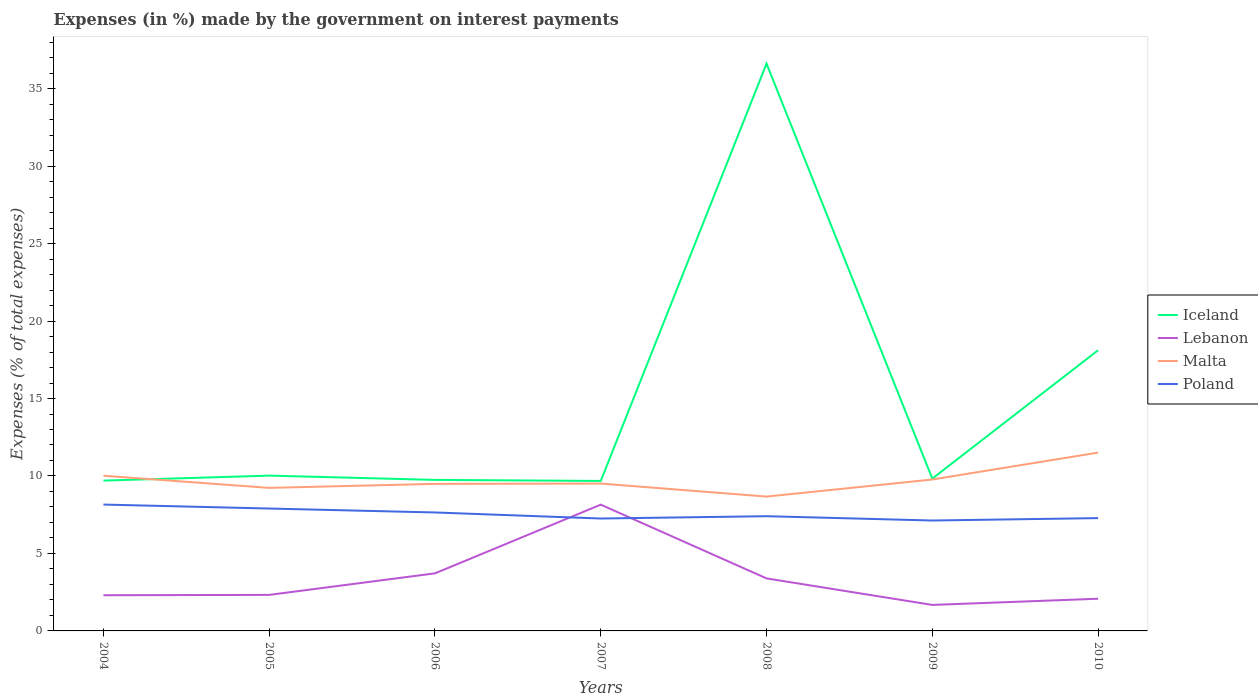Does the line corresponding to Iceland intersect with the line corresponding to Poland?
Make the answer very short. No. Is the number of lines equal to the number of legend labels?
Your answer should be compact. Yes. Across all years, what is the maximum percentage of expenses made by the government on interest payments in Poland?
Provide a succinct answer. 7.13. In which year was the percentage of expenses made by the government on interest payments in Lebanon maximum?
Your answer should be very brief. 2009. What is the total percentage of expenses made by the government on interest payments in Poland in the graph?
Give a very brief answer. 0.77. What is the difference between the highest and the second highest percentage of expenses made by the government on interest payments in Iceland?
Provide a short and direct response. 26.93. Is the percentage of expenses made by the government on interest payments in Iceland strictly greater than the percentage of expenses made by the government on interest payments in Lebanon over the years?
Keep it short and to the point. No. How many lines are there?
Ensure brevity in your answer.  4. How many years are there in the graph?
Your response must be concise. 7. What is the difference between two consecutive major ticks on the Y-axis?
Provide a succinct answer. 5. Does the graph contain any zero values?
Provide a succinct answer. No. How many legend labels are there?
Give a very brief answer. 4. How are the legend labels stacked?
Provide a short and direct response. Vertical. What is the title of the graph?
Provide a short and direct response. Expenses (in %) made by the government on interest payments. What is the label or title of the Y-axis?
Ensure brevity in your answer.  Expenses (% of total expenses). What is the Expenses (% of total expenses) in Iceland in 2004?
Provide a short and direct response. 9.7. What is the Expenses (% of total expenses) in Lebanon in 2004?
Offer a very short reply. 2.3. What is the Expenses (% of total expenses) in Malta in 2004?
Your answer should be compact. 10.02. What is the Expenses (% of total expenses) of Poland in 2004?
Your answer should be compact. 8.16. What is the Expenses (% of total expenses) of Iceland in 2005?
Your answer should be very brief. 10.02. What is the Expenses (% of total expenses) of Lebanon in 2005?
Your answer should be compact. 2.33. What is the Expenses (% of total expenses) in Malta in 2005?
Make the answer very short. 9.23. What is the Expenses (% of total expenses) of Poland in 2005?
Offer a terse response. 7.9. What is the Expenses (% of total expenses) in Iceland in 2006?
Offer a terse response. 9.75. What is the Expenses (% of total expenses) of Lebanon in 2006?
Your answer should be compact. 3.72. What is the Expenses (% of total expenses) of Malta in 2006?
Your answer should be compact. 9.49. What is the Expenses (% of total expenses) of Poland in 2006?
Offer a very short reply. 7.64. What is the Expenses (% of total expenses) of Iceland in 2007?
Give a very brief answer. 9.68. What is the Expenses (% of total expenses) in Lebanon in 2007?
Offer a very short reply. 8.15. What is the Expenses (% of total expenses) of Malta in 2007?
Give a very brief answer. 9.51. What is the Expenses (% of total expenses) of Poland in 2007?
Your answer should be compact. 7.26. What is the Expenses (% of total expenses) in Iceland in 2008?
Keep it short and to the point. 36.61. What is the Expenses (% of total expenses) in Lebanon in 2008?
Offer a very short reply. 3.39. What is the Expenses (% of total expenses) of Malta in 2008?
Your response must be concise. 8.67. What is the Expenses (% of total expenses) in Poland in 2008?
Give a very brief answer. 7.4. What is the Expenses (% of total expenses) of Iceland in 2009?
Ensure brevity in your answer.  9.83. What is the Expenses (% of total expenses) in Lebanon in 2009?
Ensure brevity in your answer.  1.68. What is the Expenses (% of total expenses) of Malta in 2009?
Ensure brevity in your answer.  9.77. What is the Expenses (% of total expenses) of Poland in 2009?
Your answer should be very brief. 7.13. What is the Expenses (% of total expenses) of Iceland in 2010?
Offer a very short reply. 18.11. What is the Expenses (% of total expenses) of Lebanon in 2010?
Ensure brevity in your answer.  2.08. What is the Expenses (% of total expenses) in Malta in 2010?
Keep it short and to the point. 11.51. What is the Expenses (% of total expenses) of Poland in 2010?
Your answer should be very brief. 7.28. Across all years, what is the maximum Expenses (% of total expenses) in Iceland?
Provide a short and direct response. 36.61. Across all years, what is the maximum Expenses (% of total expenses) of Lebanon?
Make the answer very short. 8.15. Across all years, what is the maximum Expenses (% of total expenses) of Malta?
Your response must be concise. 11.51. Across all years, what is the maximum Expenses (% of total expenses) in Poland?
Provide a succinct answer. 8.16. Across all years, what is the minimum Expenses (% of total expenses) of Iceland?
Provide a short and direct response. 9.68. Across all years, what is the minimum Expenses (% of total expenses) of Lebanon?
Provide a short and direct response. 1.68. Across all years, what is the minimum Expenses (% of total expenses) in Malta?
Keep it short and to the point. 8.67. Across all years, what is the minimum Expenses (% of total expenses) of Poland?
Your response must be concise. 7.13. What is the total Expenses (% of total expenses) of Iceland in the graph?
Provide a succinct answer. 103.71. What is the total Expenses (% of total expenses) in Lebanon in the graph?
Keep it short and to the point. 23.64. What is the total Expenses (% of total expenses) in Malta in the graph?
Provide a succinct answer. 68.2. What is the total Expenses (% of total expenses) in Poland in the graph?
Provide a short and direct response. 52.76. What is the difference between the Expenses (% of total expenses) of Iceland in 2004 and that in 2005?
Offer a terse response. -0.32. What is the difference between the Expenses (% of total expenses) of Lebanon in 2004 and that in 2005?
Ensure brevity in your answer.  -0.02. What is the difference between the Expenses (% of total expenses) of Malta in 2004 and that in 2005?
Keep it short and to the point. 0.78. What is the difference between the Expenses (% of total expenses) in Poland in 2004 and that in 2005?
Ensure brevity in your answer.  0.26. What is the difference between the Expenses (% of total expenses) of Iceland in 2004 and that in 2006?
Keep it short and to the point. -0.05. What is the difference between the Expenses (% of total expenses) in Lebanon in 2004 and that in 2006?
Provide a succinct answer. -1.41. What is the difference between the Expenses (% of total expenses) in Malta in 2004 and that in 2006?
Provide a short and direct response. 0.53. What is the difference between the Expenses (% of total expenses) in Poland in 2004 and that in 2006?
Offer a terse response. 0.51. What is the difference between the Expenses (% of total expenses) in Iceland in 2004 and that in 2007?
Ensure brevity in your answer.  0.02. What is the difference between the Expenses (% of total expenses) in Lebanon in 2004 and that in 2007?
Provide a short and direct response. -5.85. What is the difference between the Expenses (% of total expenses) in Malta in 2004 and that in 2007?
Your response must be concise. 0.51. What is the difference between the Expenses (% of total expenses) of Poland in 2004 and that in 2007?
Give a very brief answer. 0.9. What is the difference between the Expenses (% of total expenses) of Iceland in 2004 and that in 2008?
Give a very brief answer. -26.91. What is the difference between the Expenses (% of total expenses) in Lebanon in 2004 and that in 2008?
Ensure brevity in your answer.  -1.09. What is the difference between the Expenses (% of total expenses) of Malta in 2004 and that in 2008?
Give a very brief answer. 1.35. What is the difference between the Expenses (% of total expenses) in Poland in 2004 and that in 2008?
Keep it short and to the point. 0.75. What is the difference between the Expenses (% of total expenses) in Iceland in 2004 and that in 2009?
Provide a succinct answer. -0.13. What is the difference between the Expenses (% of total expenses) in Lebanon in 2004 and that in 2009?
Give a very brief answer. 0.63. What is the difference between the Expenses (% of total expenses) of Malta in 2004 and that in 2009?
Make the answer very short. 0.24. What is the difference between the Expenses (% of total expenses) in Poland in 2004 and that in 2009?
Keep it short and to the point. 1.03. What is the difference between the Expenses (% of total expenses) of Iceland in 2004 and that in 2010?
Give a very brief answer. -8.41. What is the difference between the Expenses (% of total expenses) in Lebanon in 2004 and that in 2010?
Ensure brevity in your answer.  0.23. What is the difference between the Expenses (% of total expenses) of Malta in 2004 and that in 2010?
Your answer should be very brief. -1.49. What is the difference between the Expenses (% of total expenses) of Poland in 2004 and that in 2010?
Provide a succinct answer. 0.87. What is the difference between the Expenses (% of total expenses) in Iceland in 2005 and that in 2006?
Make the answer very short. 0.28. What is the difference between the Expenses (% of total expenses) of Lebanon in 2005 and that in 2006?
Provide a short and direct response. -1.39. What is the difference between the Expenses (% of total expenses) of Malta in 2005 and that in 2006?
Make the answer very short. -0.26. What is the difference between the Expenses (% of total expenses) of Poland in 2005 and that in 2006?
Your answer should be very brief. 0.25. What is the difference between the Expenses (% of total expenses) in Iceland in 2005 and that in 2007?
Your response must be concise. 0.34. What is the difference between the Expenses (% of total expenses) of Lebanon in 2005 and that in 2007?
Provide a short and direct response. -5.82. What is the difference between the Expenses (% of total expenses) of Malta in 2005 and that in 2007?
Your answer should be compact. -0.28. What is the difference between the Expenses (% of total expenses) of Poland in 2005 and that in 2007?
Offer a very short reply. 0.64. What is the difference between the Expenses (% of total expenses) in Iceland in 2005 and that in 2008?
Offer a very short reply. -26.59. What is the difference between the Expenses (% of total expenses) in Lebanon in 2005 and that in 2008?
Offer a terse response. -1.06. What is the difference between the Expenses (% of total expenses) of Malta in 2005 and that in 2008?
Give a very brief answer. 0.56. What is the difference between the Expenses (% of total expenses) in Poland in 2005 and that in 2008?
Offer a very short reply. 0.49. What is the difference between the Expenses (% of total expenses) of Iceland in 2005 and that in 2009?
Provide a succinct answer. 0.19. What is the difference between the Expenses (% of total expenses) in Lebanon in 2005 and that in 2009?
Offer a very short reply. 0.65. What is the difference between the Expenses (% of total expenses) of Malta in 2005 and that in 2009?
Offer a very short reply. -0.54. What is the difference between the Expenses (% of total expenses) of Poland in 2005 and that in 2009?
Give a very brief answer. 0.77. What is the difference between the Expenses (% of total expenses) in Iceland in 2005 and that in 2010?
Your answer should be very brief. -8.09. What is the difference between the Expenses (% of total expenses) in Lebanon in 2005 and that in 2010?
Your answer should be compact. 0.25. What is the difference between the Expenses (% of total expenses) in Malta in 2005 and that in 2010?
Give a very brief answer. -2.28. What is the difference between the Expenses (% of total expenses) in Poland in 2005 and that in 2010?
Your response must be concise. 0.62. What is the difference between the Expenses (% of total expenses) of Iceland in 2006 and that in 2007?
Your answer should be compact. 0.07. What is the difference between the Expenses (% of total expenses) in Lebanon in 2006 and that in 2007?
Your response must be concise. -4.43. What is the difference between the Expenses (% of total expenses) in Malta in 2006 and that in 2007?
Give a very brief answer. -0.02. What is the difference between the Expenses (% of total expenses) of Poland in 2006 and that in 2007?
Your response must be concise. 0.39. What is the difference between the Expenses (% of total expenses) in Iceland in 2006 and that in 2008?
Keep it short and to the point. -26.86. What is the difference between the Expenses (% of total expenses) in Lebanon in 2006 and that in 2008?
Your answer should be compact. 0.33. What is the difference between the Expenses (% of total expenses) in Malta in 2006 and that in 2008?
Ensure brevity in your answer.  0.82. What is the difference between the Expenses (% of total expenses) in Poland in 2006 and that in 2008?
Your answer should be very brief. 0.24. What is the difference between the Expenses (% of total expenses) of Iceland in 2006 and that in 2009?
Provide a short and direct response. -0.08. What is the difference between the Expenses (% of total expenses) in Lebanon in 2006 and that in 2009?
Your response must be concise. 2.04. What is the difference between the Expenses (% of total expenses) in Malta in 2006 and that in 2009?
Your answer should be compact. -0.28. What is the difference between the Expenses (% of total expenses) in Poland in 2006 and that in 2009?
Your answer should be compact. 0.52. What is the difference between the Expenses (% of total expenses) in Iceland in 2006 and that in 2010?
Provide a succinct answer. -8.37. What is the difference between the Expenses (% of total expenses) of Lebanon in 2006 and that in 2010?
Keep it short and to the point. 1.64. What is the difference between the Expenses (% of total expenses) of Malta in 2006 and that in 2010?
Keep it short and to the point. -2.02. What is the difference between the Expenses (% of total expenses) of Poland in 2006 and that in 2010?
Your answer should be very brief. 0.36. What is the difference between the Expenses (% of total expenses) in Iceland in 2007 and that in 2008?
Your answer should be very brief. -26.93. What is the difference between the Expenses (% of total expenses) of Lebanon in 2007 and that in 2008?
Your answer should be compact. 4.76. What is the difference between the Expenses (% of total expenses) in Malta in 2007 and that in 2008?
Your answer should be compact. 0.84. What is the difference between the Expenses (% of total expenses) of Poland in 2007 and that in 2008?
Keep it short and to the point. -0.15. What is the difference between the Expenses (% of total expenses) in Iceland in 2007 and that in 2009?
Offer a terse response. -0.15. What is the difference between the Expenses (% of total expenses) in Lebanon in 2007 and that in 2009?
Make the answer very short. 6.47. What is the difference between the Expenses (% of total expenses) in Malta in 2007 and that in 2009?
Offer a terse response. -0.26. What is the difference between the Expenses (% of total expenses) of Poland in 2007 and that in 2009?
Offer a very short reply. 0.13. What is the difference between the Expenses (% of total expenses) in Iceland in 2007 and that in 2010?
Ensure brevity in your answer.  -8.43. What is the difference between the Expenses (% of total expenses) of Lebanon in 2007 and that in 2010?
Your response must be concise. 6.07. What is the difference between the Expenses (% of total expenses) of Malta in 2007 and that in 2010?
Your answer should be very brief. -2. What is the difference between the Expenses (% of total expenses) in Poland in 2007 and that in 2010?
Provide a succinct answer. -0.03. What is the difference between the Expenses (% of total expenses) of Iceland in 2008 and that in 2009?
Offer a terse response. 26.78. What is the difference between the Expenses (% of total expenses) in Lebanon in 2008 and that in 2009?
Your response must be concise. 1.71. What is the difference between the Expenses (% of total expenses) of Malta in 2008 and that in 2009?
Your response must be concise. -1.1. What is the difference between the Expenses (% of total expenses) in Poland in 2008 and that in 2009?
Your answer should be compact. 0.28. What is the difference between the Expenses (% of total expenses) in Iceland in 2008 and that in 2010?
Make the answer very short. 18.5. What is the difference between the Expenses (% of total expenses) of Lebanon in 2008 and that in 2010?
Provide a short and direct response. 1.31. What is the difference between the Expenses (% of total expenses) in Malta in 2008 and that in 2010?
Give a very brief answer. -2.84. What is the difference between the Expenses (% of total expenses) in Poland in 2008 and that in 2010?
Provide a succinct answer. 0.12. What is the difference between the Expenses (% of total expenses) in Iceland in 2009 and that in 2010?
Make the answer very short. -8.28. What is the difference between the Expenses (% of total expenses) of Lebanon in 2009 and that in 2010?
Provide a succinct answer. -0.4. What is the difference between the Expenses (% of total expenses) in Malta in 2009 and that in 2010?
Give a very brief answer. -1.74. What is the difference between the Expenses (% of total expenses) in Poland in 2009 and that in 2010?
Offer a very short reply. -0.16. What is the difference between the Expenses (% of total expenses) in Iceland in 2004 and the Expenses (% of total expenses) in Lebanon in 2005?
Give a very brief answer. 7.38. What is the difference between the Expenses (% of total expenses) of Iceland in 2004 and the Expenses (% of total expenses) of Malta in 2005?
Your response must be concise. 0.47. What is the difference between the Expenses (% of total expenses) in Iceland in 2004 and the Expenses (% of total expenses) in Poland in 2005?
Your response must be concise. 1.8. What is the difference between the Expenses (% of total expenses) of Lebanon in 2004 and the Expenses (% of total expenses) of Malta in 2005?
Offer a terse response. -6.93. What is the difference between the Expenses (% of total expenses) in Lebanon in 2004 and the Expenses (% of total expenses) in Poland in 2005?
Ensure brevity in your answer.  -5.6. What is the difference between the Expenses (% of total expenses) in Malta in 2004 and the Expenses (% of total expenses) in Poland in 2005?
Your answer should be very brief. 2.12. What is the difference between the Expenses (% of total expenses) of Iceland in 2004 and the Expenses (% of total expenses) of Lebanon in 2006?
Keep it short and to the point. 5.99. What is the difference between the Expenses (% of total expenses) of Iceland in 2004 and the Expenses (% of total expenses) of Malta in 2006?
Provide a succinct answer. 0.21. What is the difference between the Expenses (% of total expenses) in Iceland in 2004 and the Expenses (% of total expenses) in Poland in 2006?
Keep it short and to the point. 2.06. What is the difference between the Expenses (% of total expenses) in Lebanon in 2004 and the Expenses (% of total expenses) in Malta in 2006?
Provide a short and direct response. -7.19. What is the difference between the Expenses (% of total expenses) of Lebanon in 2004 and the Expenses (% of total expenses) of Poland in 2006?
Your answer should be very brief. -5.34. What is the difference between the Expenses (% of total expenses) of Malta in 2004 and the Expenses (% of total expenses) of Poland in 2006?
Keep it short and to the point. 2.37. What is the difference between the Expenses (% of total expenses) in Iceland in 2004 and the Expenses (% of total expenses) in Lebanon in 2007?
Offer a terse response. 1.55. What is the difference between the Expenses (% of total expenses) of Iceland in 2004 and the Expenses (% of total expenses) of Malta in 2007?
Keep it short and to the point. 0.19. What is the difference between the Expenses (% of total expenses) of Iceland in 2004 and the Expenses (% of total expenses) of Poland in 2007?
Your response must be concise. 2.45. What is the difference between the Expenses (% of total expenses) in Lebanon in 2004 and the Expenses (% of total expenses) in Malta in 2007?
Offer a terse response. -7.21. What is the difference between the Expenses (% of total expenses) of Lebanon in 2004 and the Expenses (% of total expenses) of Poland in 2007?
Your answer should be compact. -4.95. What is the difference between the Expenses (% of total expenses) in Malta in 2004 and the Expenses (% of total expenses) in Poland in 2007?
Ensure brevity in your answer.  2.76. What is the difference between the Expenses (% of total expenses) of Iceland in 2004 and the Expenses (% of total expenses) of Lebanon in 2008?
Your response must be concise. 6.31. What is the difference between the Expenses (% of total expenses) of Iceland in 2004 and the Expenses (% of total expenses) of Malta in 2008?
Offer a terse response. 1.03. What is the difference between the Expenses (% of total expenses) of Iceland in 2004 and the Expenses (% of total expenses) of Poland in 2008?
Give a very brief answer. 2.3. What is the difference between the Expenses (% of total expenses) of Lebanon in 2004 and the Expenses (% of total expenses) of Malta in 2008?
Offer a very short reply. -6.37. What is the difference between the Expenses (% of total expenses) of Lebanon in 2004 and the Expenses (% of total expenses) of Poland in 2008?
Your response must be concise. -5.1. What is the difference between the Expenses (% of total expenses) in Malta in 2004 and the Expenses (% of total expenses) in Poland in 2008?
Offer a terse response. 2.61. What is the difference between the Expenses (% of total expenses) in Iceland in 2004 and the Expenses (% of total expenses) in Lebanon in 2009?
Your answer should be very brief. 8.02. What is the difference between the Expenses (% of total expenses) in Iceland in 2004 and the Expenses (% of total expenses) in Malta in 2009?
Offer a very short reply. -0.07. What is the difference between the Expenses (% of total expenses) in Iceland in 2004 and the Expenses (% of total expenses) in Poland in 2009?
Offer a very short reply. 2.58. What is the difference between the Expenses (% of total expenses) of Lebanon in 2004 and the Expenses (% of total expenses) of Malta in 2009?
Give a very brief answer. -7.47. What is the difference between the Expenses (% of total expenses) of Lebanon in 2004 and the Expenses (% of total expenses) of Poland in 2009?
Offer a terse response. -4.82. What is the difference between the Expenses (% of total expenses) of Malta in 2004 and the Expenses (% of total expenses) of Poland in 2009?
Provide a succinct answer. 2.89. What is the difference between the Expenses (% of total expenses) of Iceland in 2004 and the Expenses (% of total expenses) of Lebanon in 2010?
Provide a succinct answer. 7.62. What is the difference between the Expenses (% of total expenses) in Iceland in 2004 and the Expenses (% of total expenses) in Malta in 2010?
Your answer should be very brief. -1.81. What is the difference between the Expenses (% of total expenses) of Iceland in 2004 and the Expenses (% of total expenses) of Poland in 2010?
Your answer should be compact. 2.42. What is the difference between the Expenses (% of total expenses) in Lebanon in 2004 and the Expenses (% of total expenses) in Malta in 2010?
Your response must be concise. -9.21. What is the difference between the Expenses (% of total expenses) of Lebanon in 2004 and the Expenses (% of total expenses) of Poland in 2010?
Your response must be concise. -4.98. What is the difference between the Expenses (% of total expenses) of Malta in 2004 and the Expenses (% of total expenses) of Poland in 2010?
Provide a short and direct response. 2.74. What is the difference between the Expenses (% of total expenses) of Iceland in 2005 and the Expenses (% of total expenses) of Lebanon in 2006?
Offer a terse response. 6.31. What is the difference between the Expenses (% of total expenses) in Iceland in 2005 and the Expenses (% of total expenses) in Malta in 2006?
Provide a succinct answer. 0.53. What is the difference between the Expenses (% of total expenses) in Iceland in 2005 and the Expenses (% of total expenses) in Poland in 2006?
Give a very brief answer. 2.38. What is the difference between the Expenses (% of total expenses) of Lebanon in 2005 and the Expenses (% of total expenses) of Malta in 2006?
Offer a terse response. -7.16. What is the difference between the Expenses (% of total expenses) in Lebanon in 2005 and the Expenses (% of total expenses) in Poland in 2006?
Your response must be concise. -5.32. What is the difference between the Expenses (% of total expenses) in Malta in 2005 and the Expenses (% of total expenses) in Poland in 2006?
Provide a short and direct response. 1.59. What is the difference between the Expenses (% of total expenses) in Iceland in 2005 and the Expenses (% of total expenses) in Lebanon in 2007?
Offer a terse response. 1.87. What is the difference between the Expenses (% of total expenses) of Iceland in 2005 and the Expenses (% of total expenses) of Malta in 2007?
Offer a terse response. 0.51. What is the difference between the Expenses (% of total expenses) of Iceland in 2005 and the Expenses (% of total expenses) of Poland in 2007?
Ensure brevity in your answer.  2.77. What is the difference between the Expenses (% of total expenses) in Lebanon in 2005 and the Expenses (% of total expenses) in Malta in 2007?
Offer a terse response. -7.18. What is the difference between the Expenses (% of total expenses) in Lebanon in 2005 and the Expenses (% of total expenses) in Poland in 2007?
Provide a short and direct response. -4.93. What is the difference between the Expenses (% of total expenses) of Malta in 2005 and the Expenses (% of total expenses) of Poland in 2007?
Your answer should be compact. 1.98. What is the difference between the Expenses (% of total expenses) in Iceland in 2005 and the Expenses (% of total expenses) in Lebanon in 2008?
Offer a very short reply. 6.63. What is the difference between the Expenses (% of total expenses) of Iceland in 2005 and the Expenses (% of total expenses) of Malta in 2008?
Provide a short and direct response. 1.35. What is the difference between the Expenses (% of total expenses) in Iceland in 2005 and the Expenses (% of total expenses) in Poland in 2008?
Offer a very short reply. 2.62. What is the difference between the Expenses (% of total expenses) in Lebanon in 2005 and the Expenses (% of total expenses) in Malta in 2008?
Provide a succinct answer. -6.34. What is the difference between the Expenses (% of total expenses) of Lebanon in 2005 and the Expenses (% of total expenses) of Poland in 2008?
Keep it short and to the point. -5.08. What is the difference between the Expenses (% of total expenses) in Malta in 2005 and the Expenses (% of total expenses) in Poland in 2008?
Give a very brief answer. 1.83. What is the difference between the Expenses (% of total expenses) of Iceland in 2005 and the Expenses (% of total expenses) of Lebanon in 2009?
Offer a very short reply. 8.34. What is the difference between the Expenses (% of total expenses) of Iceland in 2005 and the Expenses (% of total expenses) of Malta in 2009?
Make the answer very short. 0.25. What is the difference between the Expenses (% of total expenses) of Iceland in 2005 and the Expenses (% of total expenses) of Poland in 2009?
Provide a succinct answer. 2.9. What is the difference between the Expenses (% of total expenses) in Lebanon in 2005 and the Expenses (% of total expenses) in Malta in 2009?
Give a very brief answer. -7.45. What is the difference between the Expenses (% of total expenses) of Lebanon in 2005 and the Expenses (% of total expenses) of Poland in 2009?
Your answer should be very brief. -4.8. What is the difference between the Expenses (% of total expenses) in Malta in 2005 and the Expenses (% of total expenses) in Poland in 2009?
Your response must be concise. 2.11. What is the difference between the Expenses (% of total expenses) of Iceland in 2005 and the Expenses (% of total expenses) of Lebanon in 2010?
Offer a very short reply. 7.94. What is the difference between the Expenses (% of total expenses) in Iceland in 2005 and the Expenses (% of total expenses) in Malta in 2010?
Make the answer very short. -1.49. What is the difference between the Expenses (% of total expenses) in Iceland in 2005 and the Expenses (% of total expenses) in Poland in 2010?
Offer a terse response. 2.74. What is the difference between the Expenses (% of total expenses) in Lebanon in 2005 and the Expenses (% of total expenses) in Malta in 2010?
Offer a terse response. -9.18. What is the difference between the Expenses (% of total expenses) in Lebanon in 2005 and the Expenses (% of total expenses) in Poland in 2010?
Your answer should be compact. -4.95. What is the difference between the Expenses (% of total expenses) of Malta in 2005 and the Expenses (% of total expenses) of Poland in 2010?
Offer a terse response. 1.95. What is the difference between the Expenses (% of total expenses) of Iceland in 2006 and the Expenses (% of total expenses) of Lebanon in 2007?
Keep it short and to the point. 1.6. What is the difference between the Expenses (% of total expenses) in Iceland in 2006 and the Expenses (% of total expenses) in Malta in 2007?
Keep it short and to the point. 0.24. What is the difference between the Expenses (% of total expenses) of Iceland in 2006 and the Expenses (% of total expenses) of Poland in 2007?
Provide a succinct answer. 2.49. What is the difference between the Expenses (% of total expenses) of Lebanon in 2006 and the Expenses (% of total expenses) of Malta in 2007?
Provide a short and direct response. -5.79. What is the difference between the Expenses (% of total expenses) in Lebanon in 2006 and the Expenses (% of total expenses) in Poland in 2007?
Give a very brief answer. -3.54. What is the difference between the Expenses (% of total expenses) in Malta in 2006 and the Expenses (% of total expenses) in Poland in 2007?
Make the answer very short. 2.24. What is the difference between the Expenses (% of total expenses) in Iceland in 2006 and the Expenses (% of total expenses) in Lebanon in 2008?
Offer a terse response. 6.36. What is the difference between the Expenses (% of total expenses) in Iceland in 2006 and the Expenses (% of total expenses) in Malta in 2008?
Offer a terse response. 1.08. What is the difference between the Expenses (% of total expenses) of Iceland in 2006 and the Expenses (% of total expenses) of Poland in 2008?
Give a very brief answer. 2.34. What is the difference between the Expenses (% of total expenses) in Lebanon in 2006 and the Expenses (% of total expenses) in Malta in 2008?
Offer a very short reply. -4.95. What is the difference between the Expenses (% of total expenses) of Lebanon in 2006 and the Expenses (% of total expenses) of Poland in 2008?
Your response must be concise. -3.69. What is the difference between the Expenses (% of total expenses) of Malta in 2006 and the Expenses (% of total expenses) of Poland in 2008?
Make the answer very short. 2.09. What is the difference between the Expenses (% of total expenses) of Iceland in 2006 and the Expenses (% of total expenses) of Lebanon in 2009?
Offer a terse response. 8.07. What is the difference between the Expenses (% of total expenses) in Iceland in 2006 and the Expenses (% of total expenses) in Malta in 2009?
Your response must be concise. -0.03. What is the difference between the Expenses (% of total expenses) in Iceland in 2006 and the Expenses (% of total expenses) in Poland in 2009?
Your answer should be compact. 2.62. What is the difference between the Expenses (% of total expenses) of Lebanon in 2006 and the Expenses (% of total expenses) of Malta in 2009?
Ensure brevity in your answer.  -6.06. What is the difference between the Expenses (% of total expenses) in Lebanon in 2006 and the Expenses (% of total expenses) in Poland in 2009?
Provide a succinct answer. -3.41. What is the difference between the Expenses (% of total expenses) of Malta in 2006 and the Expenses (% of total expenses) of Poland in 2009?
Your answer should be very brief. 2.37. What is the difference between the Expenses (% of total expenses) of Iceland in 2006 and the Expenses (% of total expenses) of Lebanon in 2010?
Your answer should be very brief. 7.67. What is the difference between the Expenses (% of total expenses) in Iceland in 2006 and the Expenses (% of total expenses) in Malta in 2010?
Offer a very short reply. -1.76. What is the difference between the Expenses (% of total expenses) in Iceland in 2006 and the Expenses (% of total expenses) in Poland in 2010?
Provide a succinct answer. 2.47. What is the difference between the Expenses (% of total expenses) of Lebanon in 2006 and the Expenses (% of total expenses) of Malta in 2010?
Your response must be concise. -7.79. What is the difference between the Expenses (% of total expenses) in Lebanon in 2006 and the Expenses (% of total expenses) in Poland in 2010?
Make the answer very short. -3.57. What is the difference between the Expenses (% of total expenses) in Malta in 2006 and the Expenses (% of total expenses) in Poland in 2010?
Ensure brevity in your answer.  2.21. What is the difference between the Expenses (% of total expenses) of Iceland in 2007 and the Expenses (% of total expenses) of Lebanon in 2008?
Provide a succinct answer. 6.29. What is the difference between the Expenses (% of total expenses) of Iceland in 2007 and the Expenses (% of total expenses) of Malta in 2008?
Offer a terse response. 1.01. What is the difference between the Expenses (% of total expenses) in Iceland in 2007 and the Expenses (% of total expenses) in Poland in 2008?
Your response must be concise. 2.28. What is the difference between the Expenses (% of total expenses) in Lebanon in 2007 and the Expenses (% of total expenses) in Malta in 2008?
Offer a very short reply. -0.52. What is the difference between the Expenses (% of total expenses) in Lebanon in 2007 and the Expenses (% of total expenses) in Poland in 2008?
Provide a succinct answer. 0.74. What is the difference between the Expenses (% of total expenses) in Malta in 2007 and the Expenses (% of total expenses) in Poland in 2008?
Your response must be concise. 2.11. What is the difference between the Expenses (% of total expenses) of Iceland in 2007 and the Expenses (% of total expenses) of Lebanon in 2009?
Ensure brevity in your answer.  8. What is the difference between the Expenses (% of total expenses) of Iceland in 2007 and the Expenses (% of total expenses) of Malta in 2009?
Provide a short and direct response. -0.09. What is the difference between the Expenses (% of total expenses) of Iceland in 2007 and the Expenses (% of total expenses) of Poland in 2009?
Ensure brevity in your answer.  2.56. What is the difference between the Expenses (% of total expenses) of Lebanon in 2007 and the Expenses (% of total expenses) of Malta in 2009?
Ensure brevity in your answer.  -1.62. What is the difference between the Expenses (% of total expenses) of Lebanon in 2007 and the Expenses (% of total expenses) of Poland in 2009?
Keep it short and to the point. 1.02. What is the difference between the Expenses (% of total expenses) of Malta in 2007 and the Expenses (% of total expenses) of Poland in 2009?
Make the answer very short. 2.39. What is the difference between the Expenses (% of total expenses) in Iceland in 2007 and the Expenses (% of total expenses) in Lebanon in 2010?
Provide a short and direct response. 7.6. What is the difference between the Expenses (% of total expenses) of Iceland in 2007 and the Expenses (% of total expenses) of Malta in 2010?
Provide a succinct answer. -1.83. What is the difference between the Expenses (% of total expenses) in Iceland in 2007 and the Expenses (% of total expenses) in Poland in 2010?
Keep it short and to the point. 2.4. What is the difference between the Expenses (% of total expenses) in Lebanon in 2007 and the Expenses (% of total expenses) in Malta in 2010?
Ensure brevity in your answer.  -3.36. What is the difference between the Expenses (% of total expenses) in Lebanon in 2007 and the Expenses (% of total expenses) in Poland in 2010?
Give a very brief answer. 0.87. What is the difference between the Expenses (% of total expenses) of Malta in 2007 and the Expenses (% of total expenses) of Poland in 2010?
Your answer should be very brief. 2.23. What is the difference between the Expenses (% of total expenses) of Iceland in 2008 and the Expenses (% of total expenses) of Lebanon in 2009?
Your answer should be very brief. 34.93. What is the difference between the Expenses (% of total expenses) of Iceland in 2008 and the Expenses (% of total expenses) of Malta in 2009?
Your answer should be very brief. 26.84. What is the difference between the Expenses (% of total expenses) in Iceland in 2008 and the Expenses (% of total expenses) in Poland in 2009?
Keep it short and to the point. 29.49. What is the difference between the Expenses (% of total expenses) of Lebanon in 2008 and the Expenses (% of total expenses) of Malta in 2009?
Keep it short and to the point. -6.38. What is the difference between the Expenses (% of total expenses) of Lebanon in 2008 and the Expenses (% of total expenses) of Poland in 2009?
Offer a terse response. -3.74. What is the difference between the Expenses (% of total expenses) of Malta in 2008 and the Expenses (% of total expenses) of Poland in 2009?
Make the answer very short. 1.54. What is the difference between the Expenses (% of total expenses) in Iceland in 2008 and the Expenses (% of total expenses) in Lebanon in 2010?
Keep it short and to the point. 34.53. What is the difference between the Expenses (% of total expenses) of Iceland in 2008 and the Expenses (% of total expenses) of Malta in 2010?
Ensure brevity in your answer.  25.1. What is the difference between the Expenses (% of total expenses) of Iceland in 2008 and the Expenses (% of total expenses) of Poland in 2010?
Provide a short and direct response. 29.33. What is the difference between the Expenses (% of total expenses) in Lebanon in 2008 and the Expenses (% of total expenses) in Malta in 2010?
Your response must be concise. -8.12. What is the difference between the Expenses (% of total expenses) in Lebanon in 2008 and the Expenses (% of total expenses) in Poland in 2010?
Your answer should be very brief. -3.89. What is the difference between the Expenses (% of total expenses) in Malta in 2008 and the Expenses (% of total expenses) in Poland in 2010?
Keep it short and to the point. 1.39. What is the difference between the Expenses (% of total expenses) of Iceland in 2009 and the Expenses (% of total expenses) of Lebanon in 2010?
Offer a very short reply. 7.75. What is the difference between the Expenses (% of total expenses) in Iceland in 2009 and the Expenses (% of total expenses) in Malta in 2010?
Offer a very short reply. -1.68. What is the difference between the Expenses (% of total expenses) of Iceland in 2009 and the Expenses (% of total expenses) of Poland in 2010?
Provide a short and direct response. 2.55. What is the difference between the Expenses (% of total expenses) of Lebanon in 2009 and the Expenses (% of total expenses) of Malta in 2010?
Keep it short and to the point. -9.83. What is the difference between the Expenses (% of total expenses) in Lebanon in 2009 and the Expenses (% of total expenses) in Poland in 2010?
Offer a very short reply. -5.6. What is the difference between the Expenses (% of total expenses) of Malta in 2009 and the Expenses (% of total expenses) of Poland in 2010?
Ensure brevity in your answer.  2.49. What is the average Expenses (% of total expenses) in Iceland per year?
Offer a very short reply. 14.82. What is the average Expenses (% of total expenses) in Lebanon per year?
Offer a very short reply. 3.38. What is the average Expenses (% of total expenses) in Malta per year?
Offer a terse response. 9.74. What is the average Expenses (% of total expenses) of Poland per year?
Keep it short and to the point. 7.54. In the year 2004, what is the difference between the Expenses (% of total expenses) of Iceland and Expenses (% of total expenses) of Lebanon?
Provide a succinct answer. 7.4. In the year 2004, what is the difference between the Expenses (% of total expenses) in Iceland and Expenses (% of total expenses) in Malta?
Your response must be concise. -0.32. In the year 2004, what is the difference between the Expenses (% of total expenses) of Iceland and Expenses (% of total expenses) of Poland?
Provide a succinct answer. 1.55. In the year 2004, what is the difference between the Expenses (% of total expenses) of Lebanon and Expenses (% of total expenses) of Malta?
Offer a very short reply. -7.71. In the year 2004, what is the difference between the Expenses (% of total expenses) of Lebanon and Expenses (% of total expenses) of Poland?
Give a very brief answer. -5.85. In the year 2004, what is the difference between the Expenses (% of total expenses) of Malta and Expenses (% of total expenses) of Poland?
Offer a very short reply. 1.86. In the year 2005, what is the difference between the Expenses (% of total expenses) of Iceland and Expenses (% of total expenses) of Lebanon?
Offer a very short reply. 7.7. In the year 2005, what is the difference between the Expenses (% of total expenses) of Iceland and Expenses (% of total expenses) of Malta?
Your response must be concise. 0.79. In the year 2005, what is the difference between the Expenses (% of total expenses) in Iceland and Expenses (% of total expenses) in Poland?
Your response must be concise. 2.12. In the year 2005, what is the difference between the Expenses (% of total expenses) of Lebanon and Expenses (% of total expenses) of Malta?
Offer a terse response. -6.91. In the year 2005, what is the difference between the Expenses (% of total expenses) in Lebanon and Expenses (% of total expenses) in Poland?
Your response must be concise. -5.57. In the year 2005, what is the difference between the Expenses (% of total expenses) of Malta and Expenses (% of total expenses) of Poland?
Your answer should be very brief. 1.33. In the year 2006, what is the difference between the Expenses (% of total expenses) in Iceland and Expenses (% of total expenses) in Lebanon?
Offer a terse response. 6.03. In the year 2006, what is the difference between the Expenses (% of total expenses) in Iceland and Expenses (% of total expenses) in Malta?
Give a very brief answer. 0.26. In the year 2006, what is the difference between the Expenses (% of total expenses) of Iceland and Expenses (% of total expenses) of Poland?
Ensure brevity in your answer.  2.1. In the year 2006, what is the difference between the Expenses (% of total expenses) in Lebanon and Expenses (% of total expenses) in Malta?
Offer a terse response. -5.78. In the year 2006, what is the difference between the Expenses (% of total expenses) of Lebanon and Expenses (% of total expenses) of Poland?
Provide a succinct answer. -3.93. In the year 2006, what is the difference between the Expenses (% of total expenses) in Malta and Expenses (% of total expenses) in Poland?
Provide a succinct answer. 1.85. In the year 2007, what is the difference between the Expenses (% of total expenses) of Iceland and Expenses (% of total expenses) of Lebanon?
Keep it short and to the point. 1.53. In the year 2007, what is the difference between the Expenses (% of total expenses) of Iceland and Expenses (% of total expenses) of Malta?
Keep it short and to the point. 0.17. In the year 2007, what is the difference between the Expenses (% of total expenses) of Iceland and Expenses (% of total expenses) of Poland?
Ensure brevity in your answer.  2.43. In the year 2007, what is the difference between the Expenses (% of total expenses) in Lebanon and Expenses (% of total expenses) in Malta?
Provide a short and direct response. -1.36. In the year 2007, what is the difference between the Expenses (% of total expenses) of Lebanon and Expenses (% of total expenses) of Poland?
Ensure brevity in your answer.  0.89. In the year 2007, what is the difference between the Expenses (% of total expenses) in Malta and Expenses (% of total expenses) in Poland?
Offer a very short reply. 2.26. In the year 2008, what is the difference between the Expenses (% of total expenses) of Iceland and Expenses (% of total expenses) of Lebanon?
Your answer should be very brief. 33.22. In the year 2008, what is the difference between the Expenses (% of total expenses) in Iceland and Expenses (% of total expenses) in Malta?
Offer a terse response. 27.94. In the year 2008, what is the difference between the Expenses (% of total expenses) of Iceland and Expenses (% of total expenses) of Poland?
Ensure brevity in your answer.  29.21. In the year 2008, what is the difference between the Expenses (% of total expenses) of Lebanon and Expenses (% of total expenses) of Malta?
Your answer should be very brief. -5.28. In the year 2008, what is the difference between the Expenses (% of total expenses) in Lebanon and Expenses (% of total expenses) in Poland?
Provide a succinct answer. -4.01. In the year 2008, what is the difference between the Expenses (% of total expenses) of Malta and Expenses (% of total expenses) of Poland?
Keep it short and to the point. 1.27. In the year 2009, what is the difference between the Expenses (% of total expenses) of Iceland and Expenses (% of total expenses) of Lebanon?
Make the answer very short. 8.15. In the year 2009, what is the difference between the Expenses (% of total expenses) in Iceland and Expenses (% of total expenses) in Malta?
Your answer should be very brief. 0.06. In the year 2009, what is the difference between the Expenses (% of total expenses) in Iceland and Expenses (% of total expenses) in Poland?
Provide a succinct answer. 2.7. In the year 2009, what is the difference between the Expenses (% of total expenses) in Lebanon and Expenses (% of total expenses) in Malta?
Offer a terse response. -8.09. In the year 2009, what is the difference between the Expenses (% of total expenses) of Lebanon and Expenses (% of total expenses) of Poland?
Your answer should be very brief. -5.45. In the year 2009, what is the difference between the Expenses (% of total expenses) in Malta and Expenses (% of total expenses) in Poland?
Ensure brevity in your answer.  2.65. In the year 2010, what is the difference between the Expenses (% of total expenses) of Iceland and Expenses (% of total expenses) of Lebanon?
Ensure brevity in your answer.  16.04. In the year 2010, what is the difference between the Expenses (% of total expenses) in Iceland and Expenses (% of total expenses) in Malta?
Offer a terse response. 6.61. In the year 2010, what is the difference between the Expenses (% of total expenses) in Iceland and Expenses (% of total expenses) in Poland?
Provide a succinct answer. 10.83. In the year 2010, what is the difference between the Expenses (% of total expenses) in Lebanon and Expenses (% of total expenses) in Malta?
Your response must be concise. -9.43. In the year 2010, what is the difference between the Expenses (% of total expenses) of Lebanon and Expenses (% of total expenses) of Poland?
Ensure brevity in your answer.  -5.2. In the year 2010, what is the difference between the Expenses (% of total expenses) in Malta and Expenses (% of total expenses) in Poland?
Give a very brief answer. 4.23. What is the ratio of the Expenses (% of total expenses) of Iceland in 2004 to that in 2005?
Provide a succinct answer. 0.97. What is the ratio of the Expenses (% of total expenses) in Lebanon in 2004 to that in 2005?
Give a very brief answer. 0.99. What is the ratio of the Expenses (% of total expenses) of Malta in 2004 to that in 2005?
Provide a short and direct response. 1.08. What is the ratio of the Expenses (% of total expenses) in Poland in 2004 to that in 2005?
Give a very brief answer. 1.03. What is the ratio of the Expenses (% of total expenses) of Iceland in 2004 to that in 2006?
Make the answer very short. 1. What is the ratio of the Expenses (% of total expenses) of Lebanon in 2004 to that in 2006?
Offer a terse response. 0.62. What is the ratio of the Expenses (% of total expenses) of Malta in 2004 to that in 2006?
Ensure brevity in your answer.  1.06. What is the ratio of the Expenses (% of total expenses) of Poland in 2004 to that in 2006?
Offer a very short reply. 1.07. What is the ratio of the Expenses (% of total expenses) in Lebanon in 2004 to that in 2007?
Make the answer very short. 0.28. What is the ratio of the Expenses (% of total expenses) in Malta in 2004 to that in 2007?
Your answer should be compact. 1.05. What is the ratio of the Expenses (% of total expenses) in Poland in 2004 to that in 2007?
Offer a very short reply. 1.12. What is the ratio of the Expenses (% of total expenses) in Iceland in 2004 to that in 2008?
Give a very brief answer. 0.27. What is the ratio of the Expenses (% of total expenses) in Lebanon in 2004 to that in 2008?
Provide a short and direct response. 0.68. What is the ratio of the Expenses (% of total expenses) in Malta in 2004 to that in 2008?
Keep it short and to the point. 1.16. What is the ratio of the Expenses (% of total expenses) in Poland in 2004 to that in 2008?
Offer a terse response. 1.1. What is the ratio of the Expenses (% of total expenses) of Iceland in 2004 to that in 2009?
Your answer should be compact. 0.99. What is the ratio of the Expenses (% of total expenses) of Lebanon in 2004 to that in 2009?
Provide a succinct answer. 1.37. What is the ratio of the Expenses (% of total expenses) in Poland in 2004 to that in 2009?
Provide a short and direct response. 1.14. What is the ratio of the Expenses (% of total expenses) of Iceland in 2004 to that in 2010?
Your answer should be very brief. 0.54. What is the ratio of the Expenses (% of total expenses) of Lebanon in 2004 to that in 2010?
Provide a succinct answer. 1.11. What is the ratio of the Expenses (% of total expenses) of Malta in 2004 to that in 2010?
Provide a short and direct response. 0.87. What is the ratio of the Expenses (% of total expenses) of Poland in 2004 to that in 2010?
Your response must be concise. 1.12. What is the ratio of the Expenses (% of total expenses) of Iceland in 2005 to that in 2006?
Keep it short and to the point. 1.03. What is the ratio of the Expenses (% of total expenses) of Lebanon in 2005 to that in 2006?
Your answer should be compact. 0.63. What is the ratio of the Expenses (% of total expenses) of Malta in 2005 to that in 2006?
Ensure brevity in your answer.  0.97. What is the ratio of the Expenses (% of total expenses) in Iceland in 2005 to that in 2007?
Your answer should be very brief. 1.04. What is the ratio of the Expenses (% of total expenses) of Lebanon in 2005 to that in 2007?
Offer a terse response. 0.29. What is the ratio of the Expenses (% of total expenses) in Malta in 2005 to that in 2007?
Make the answer very short. 0.97. What is the ratio of the Expenses (% of total expenses) in Poland in 2005 to that in 2007?
Provide a succinct answer. 1.09. What is the ratio of the Expenses (% of total expenses) in Iceland in 2005 to that in 2008?
Your response must be concise. 0.27. What is the ratio of the Expenses (% of total expenses) in Lebanon in 2005 to that in 2008?
Offer a very short reply. 0.69. What is the ratio of the Expenses (% of total expenses) of Malta in 2005 to that in 2008?
Provide a short and direct response. 1.06. What is the ratio of the Expenses (% of total expenses) in Poland in 2005 to that in 2008?
Your answer should be very brief. 1.07. What is the ratio of the Expenses (% of total expenses) in Iceland in 2005 to that in 2009?
Provide a succinct answer. 1.02. What is the ratio of the Expenses (% of total expenses) in Lebanon in 2005 to that in 2009?
Your answer should be compact. 1.39. What is the ratio of the Expenses (% of total expenses) in Malta in 2005 to that in 2009?
Ensure brevity in your answer.  0.94. What is the ratio of the Expenses (% of total expenses) of Poland in 2005 to that in 2009?
Offer a very short reply. 1.11. What is the ratio of the Expenses (% of total expenses) of Iceland in 2005 to that in 2010?
Offer a terse response. 0.55. What is the ratio of the Expenses (% of total expenses) of Lebanon in 2005 to that in 2010?
Offer a terse response. 1.12. What is the ratio of the Expenses (% of total expenses) of Malta in 2005 to that in 2010?
Provide a succinct answer. 0.8. What is the ratio of the Expenses (% of total expenses) of Poland in 2005 to that in 2010?
Offer a terse response. 1.08. What is the ratio of the Expenses (% of total expenses) in Lebanon in 2006 to that in 2007?
Your response must be concise. 0.46. What is the ratio of the Expenses (% of total expenses) in Poland in 2006 to that in 2007?
Provide a succinct answer. 1.05. What is the ratio of the Expenses (% of total expenses) in Iceland in 2006 to that in 2008?
Offer a very short reply. 0.27. What is the ratio of the Expenses (% of total expenses) of Lebanon in 2006 to that in 2008?
Keep it short and to the point. 1.1. What is the ratio of the Expenses (% of total expenses) in Malta in 2006 to that in 2008?
Provide a succinct answer. 1.09. What is the ratio of the Expenses (% of total expenses) of Poland in 2006 to that in 2008?
Offer a very short reply. 1.03. What is the ratio of the Expenses (% of total expenses) of Lebanon in 2006 to that in 2009?
Offer a terse response. 2.21. What is the ratio of the Expenses (% of total expenses) of Malta in 2006 to that in 2009?
Your answer should be very brief. 0.97. What is the ratio of the Expenses (% of total expenses) in Poland in 2006 to that in 2009?
Make the answer very short. 1.07. What is the ratio of the Expenses (% of total expenses) in Iceland in 2006 to that in 2010?
Keep it short and to the point. 0.54. What is the ratio of the Expenses (% of total expenses) of Lebanon in 2006 to that in 2010?
Keep it short and to the point. 1.79. What is the ratio of the Expenses (% of total expenses) in Malta in 2006 to that in 2010?
Offer a terse response. 0.82. What is the ratio of the Expenses (% of total expenses) in Iceland in 2007 to that in 2008?
Ensure brevity in your answer.  0.26. What is the ratio of the Expenses (% of total expenses) of Lebanon in 2007 to that in 2008?
Your response must be concise. 2.4. What is the ratio of the Expenses (% of total expenses) of Malta in 2007 to that in 2008?
Offer a terse response. 1.1. What is the ratio of the Expenses (% of total expenses) of Poland in 2007 to that in 2008?
Provide a succinct answer. 0.98. What is the ratio of the Expenses (% of total expenses) of Lebanon in 2007 to that in 2009?
Keep it short and to the point. 4.86. What is the ratio of the Expenses (% of total expenses) of Malta in 2007 to that in 2009?
Offer a very short reply. 0.97. What is the ratio of the Expenses (% of total expenses) in Poland in 2007 to that in 2009?
Keep it short and to the point. 1.02. What is the ratio of the Expenses (% of total expenses) of Iceland in 2007 to that in 2010?
Your answer should be very brief. 0.53. What is the ratio of the Expenses (% of total expenses) of Lebanon in 2007 to that in 2010?
Offer a terse response. 3.92. What is the ratio of the Expenses (% of total expenses) in Malta in 2007 to that in 2010?
Make the answer very short. 0.83. What is the ratio of the Expenses (% of total expenses) in Poland in 2007 to that in 2010?
Offer a terse response. 1. What is the ratio of the Expenses (% of total expenses) of Iceland in 2008 to that in 2009?
Make the answer very short. 3.72. What is the ratio of the Expenses (% of total expenses) of Lebanon in 2008 to that in 2009?
Offer a terse response. 2.02. What is the ratio of the Expenses (% of total expenses) of Malta in 2008 to that in 2009?
Offer a very short reply. 0.89. What is the ratio of the Expenses (% of total expenses) in Poland in 2008 to that in 2009?
Your answer should be very brief. 1.04. What is the ratio of the Expenses (% of total expenses) of Iceland in 2008 to that in 2010?
Make the answer very short. 2.02. What is the ratio of the Expenses (% of total expenses) in Lebanon in 2008 to that in 2010?
Offer a terse response. 1.63. What is the ratio of the Expenses (% of total expenses) of Malta in 2008 to that in 2010?
Offer a terse response. 0.75. What is the ratio of the Expenses (% of total expenses) in Iceland in 2009 to that in 2010?
Ensure brevity in your answer.  0.54. What is the ratio of the Expenses (% of total expenses) of Lebanon in 2009 to that in 2010?
Provide a short and direct response. 0.81. What is the ratio of the Expenses (% of total expenses) of Malta in 2009 to that in 2010?
Provide a short and direct response. 0.85. What is the ratio of the Expenses (% of total expenses) of Poland in 2009 to that in 2010?
Offer a very short reply. 0.98. What is the difference between the highest and the second highest Expenses (% of total expenses) of Iceland?
Provide a short and direct response. 18.5. What is the difference between the highest and the second highest Expenses (% of total expenses) in Lebanon?
Provide a short and direct response. 4.43. What is the difference between the highest and the second highest Expenses (% of total expenses) of Malta?
Ensure brevity in your answer.  1.49. What is the difference between the highest and the second highest Expenses (% of total expenses) in Poland?
Your answer should be compact. 0.26. What is the difference between the highest and the lowest Expenses (% of total expenses) in Iceland?
Give a very brief answer. 26.93. What is the difference between the highest and the lowest Expenses (% of total expenses) of Lebanon?
Provide a succinct answer. 6.47. What is the difference between the highest and the lowest Expenses (% of total expenses) of Malta?
Keep it short and to the point. 2.84. What is the difference between the highest and the lowest Expenses (% of total expenses) of Poland?
Make the answer very short. 1.03. 